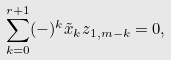<formula> <loc_0><loc_0><loc_500><loc_500>\sum _ { k = 0 } ^ { r + 1 } ( - ) ^ { k } \tilde { x } _ { k } z _ { 1 , m - k } = 0 ,</formula> 